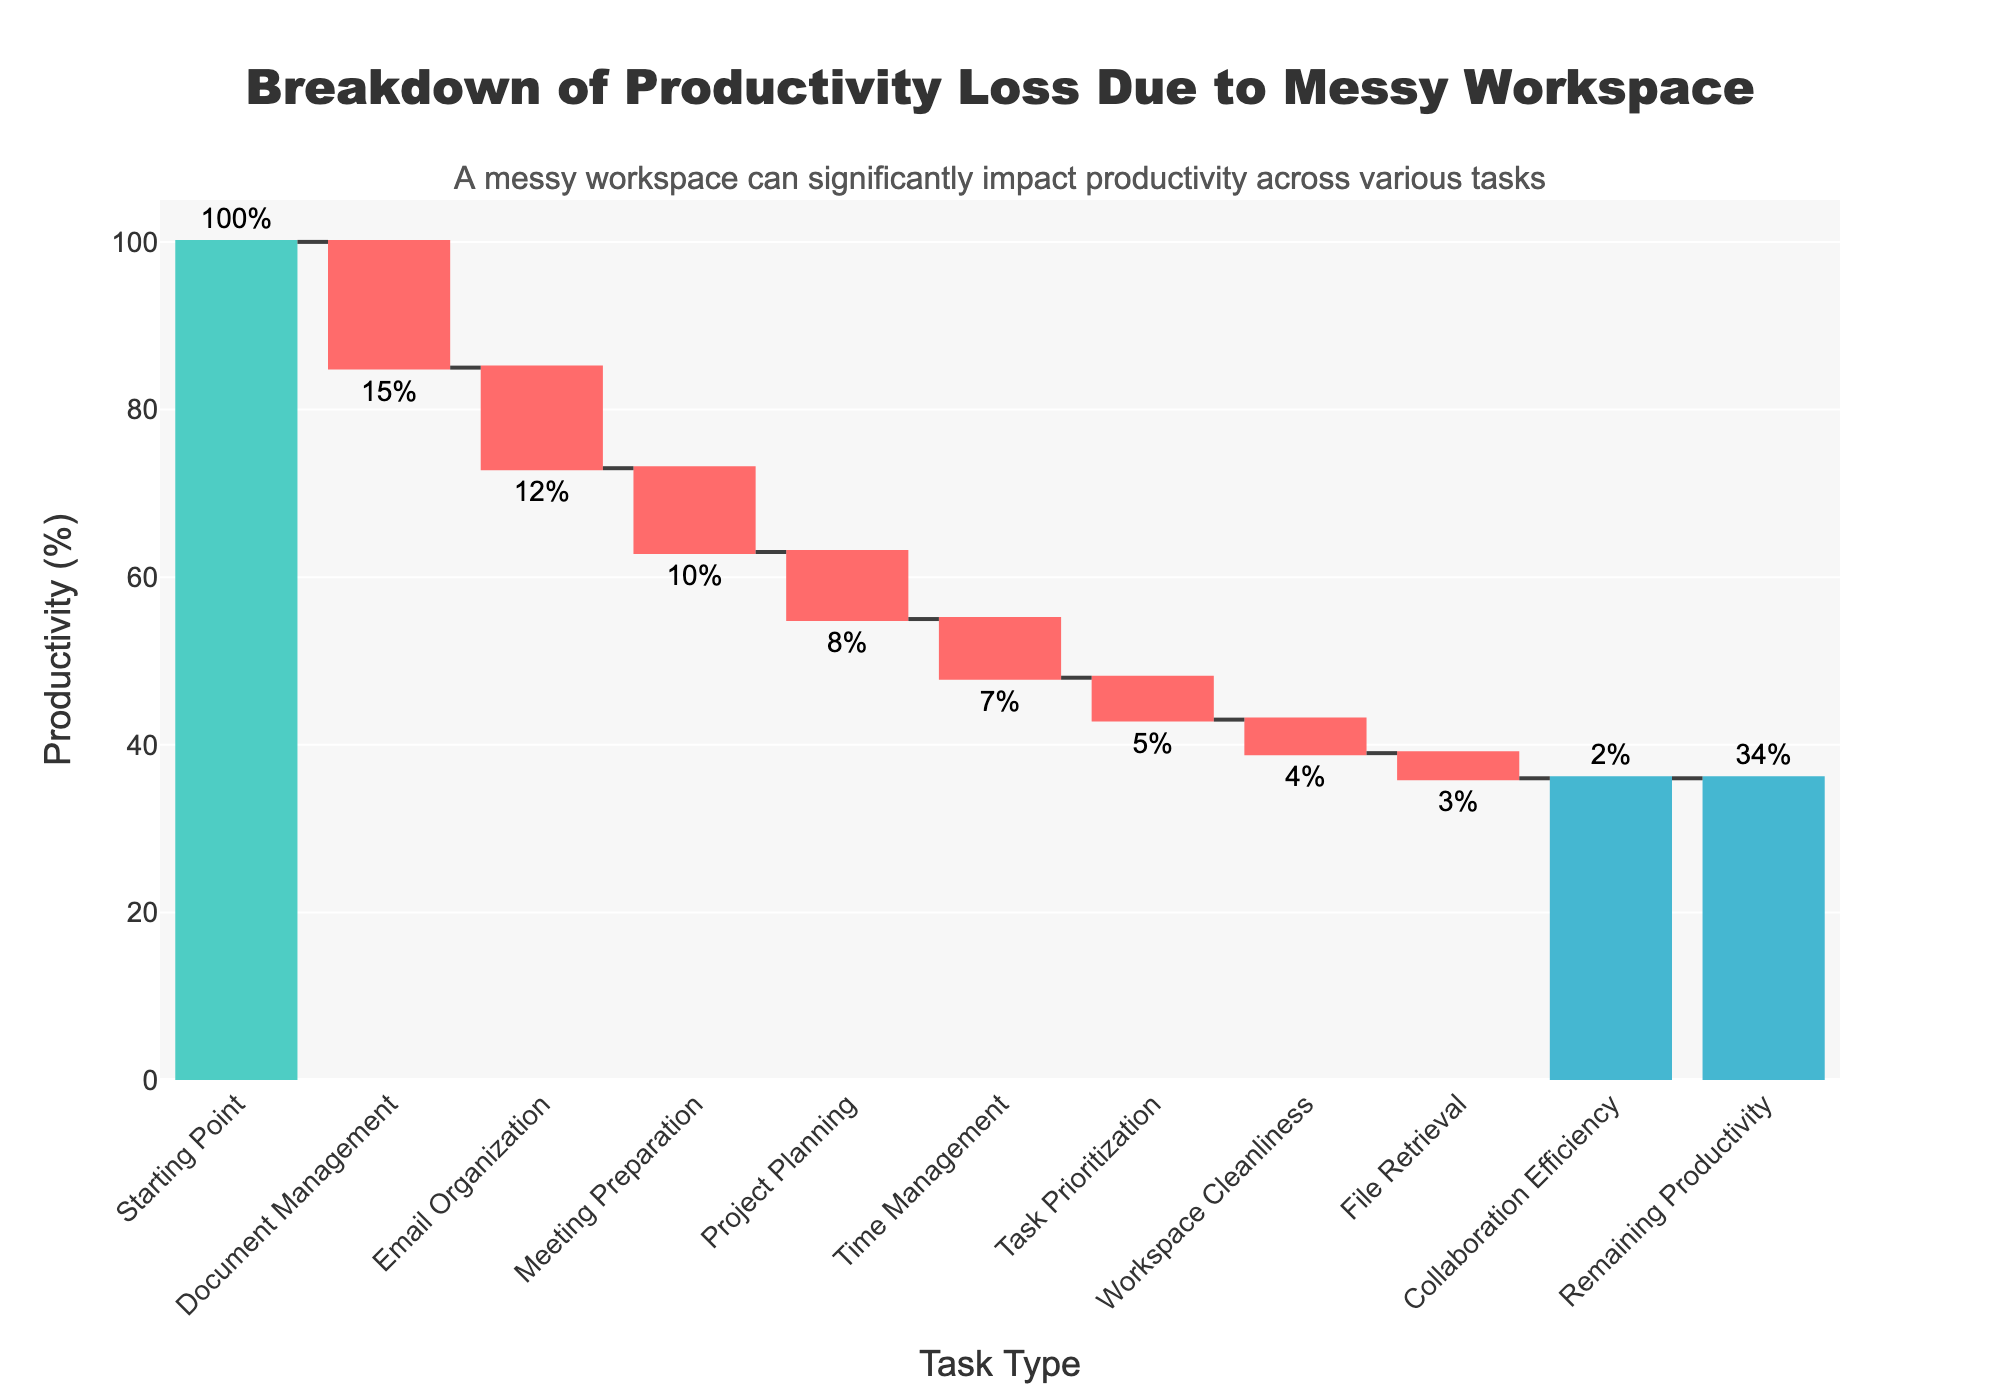What is the title of the chart? The title of the chart is typically displayed prominently at the top and summarizes the main topic of the visualization.
Answer: Breakdown of Productivity Loss Due to Messy Workspace How many task types are included in the chart? Count the number of unique task types listed along the x-axis.
Answer: 10 Which task type contributes the most to productivity loss? Identify the task type with the highest negative value, represented by the largest red segment.
Answer: Document Management What is the productivity gain from Workspace Cleanliness? Find the positive value labeled for Workspace Cleanliness in the chart.
Answer: 4% How much productivity loss is attributed to Meeting Preparation and Time Management combined? Look at the productivity loss for Meeting Preparation (-10%) and Time Management (-7%), then sum these values.
Answer: 17% Which task type has the smallest impact on productivity loss? Identify the task type with the least absolute value, represented by the smallest segment.
Answer: Collaboration Efficiency What is the remaining productivity percentage? Locate the final total segment at the end of the waterfall chart that shows the remaining percentage after accounting for all losses.
Answer: 34% What are the two task types with the closest impact on productivity loss? Compare the absolute values of losses and gains for each task type and identify the two with the closest magnitudes.
Answer: File Retrieval and Collaboration Efficiency How does the productivity loss for Project Planning compare to that of Email Organization? Look at the values for both Project Planning (-8%) and Email Organization (-12%) and determine the difference.
Answer: Project Planning has 4% less productivity loss than Email Organization What overall insight does the annotation provide? Read and interpret the annotation text added to the chart to understand the high-level insight it conveys.
Answer: A messy workspace significantly impacts productivity across various tasks 